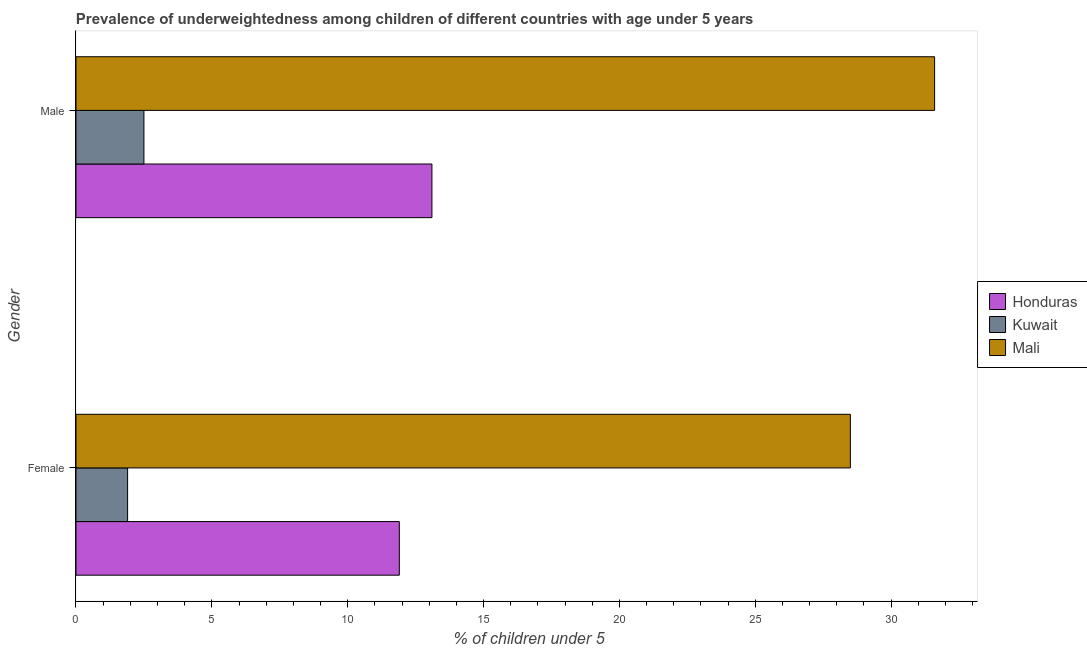What is the percentage of underweighted female children in Kuwait?
Your response must be concise. 1.9. Across all countries, what is the maximum percentage of underweighted female children?
Provide a short and direct response. 28.5. Across all countries, what is the minimum percentage of underweighted female children?
Ensure brevity in your answer.  1.9. In which country was the percentage of underweighted male children maximum?
Your response must be concise. Mali. In which country was the percentage of underweighted male children minimum?
Offer a very short reply. Kuwait. What is the total percentage of underweighted female children in the graph?
Make the answer very short. 42.3. What is the difference between the percentage of underweighted male children in Mali and that in Honduras?
Ensure brevity in your answer.  18.5. What is the difference between the percentage of underweighted male children in Mali and the percentage of underweighted female children in Honduras?
Give a very brief answer. 19.7. What is the average percentage of underweighted female children per country?
Your response must be concise. 14.1. What is the difference between the percentage of underweighted female children and percentage of underweighted male children in Kuwait?
Provide a succinct answer. -0.6. What is the ratio of the percentage of underweighted female children in Mali to that in Honduras?
Give a very brief answer. 2.39. In how many countries, is the percentage of underweighted male children greater than the average percentage of underweighted male children taken over all countries?
Offer a terse response. 1. What does the 3rd bar from the top in Male represents?
Provide a succinct answer. Honduras. What does the 2nd bar from the bottom in Male represents?
Give a very brief answer. Kuwait. How many bars are there?
Your answer should be compact. 6. Are all the bars in the graph horizontal?
Provide a succinct answer. Yes. What is the difference between two consecutive major ticks on the X-axis?
Keep it short and to the point. 5. Are the values on the major ticks of X-axis written in scientific E-notation?
Your answer should be very brief. No. How are the legend labels stacked?
Provide a short and direct response. Vertical. What is the title of the graph?
Offer a very short reply. Prevalence of underweightedness among children of different countries with age under 5 years. Does "Liechtenstein" appear as one of the legend labels in the graph?
Provide a succinct answer. No. What is the label or title of the X-axis?
Your response must be concise.  % of children under 5. What is the  % of children under 5 of Honduras in Female?
Your response must be concise. 11.9. What is the  % of children under 5 in Kuwait in Female?
Ensure brevity in your answer.  1.9. What is the  % of children under 5 in Mali in Female?
Give a very brief answer. 28.5. What is the  % of children under 5 of Honduras in Male?
Ensure brevity in your answer.  13.1. What is the  % of children under 5 in Kuwait in Male?
Provide a succinct answer. 2.5. What is the  % of children under 5 in Mali in Male?
Your answer should be very brief. 31.6. Across all Gender, what is the maximum  % of children under 5 in Honduras?
Offer a very short reply. 13.1. Across all Gender, what is the maximum  % of children under 5 of Mali?
Your answer should be compact. 31.6. Across all Gender, what is the minimum  % of children under 5 in Honduras?
Provide a succinct answer. 11.9. Across all Gender, what is the minimum  % of children under 5 in Kuwait?
Give a very brief answer. 1.9. Across all Gender, what is the minimum  % of children under 5 of Mali?
Your response must be concise. 28.5. What is the total  % of children under 5 in Honduras in the graph?
Your response must be concise. 25. What is the total  % of children under 5 of Mali in the graph?
Your response must be concise. 60.1. What is the difference between the  % of children under 5 in Mali in Female and that in Male?
Give a very brief answer. -3.1. What is the difference between the  % of children under 5 of Honduras in Female and the  % of children under 5 of Mali in Male?
Offer a terse response. -19.7. What is the difference between the  % of children under 5 in Kuwait in Female and the  % of children under 5 in Mali in Male?
Provide a succinct answer. -29.7. What is the average  % of children under 5 in Kuwait per Gender?
Keep it short and to the point. 2.2. What is the average  % of children under 5 in Mali per Gender?
Your answer should be compact. 30.05. What is the difference between the  % of children under 5 of Honduras and  % of children under 5 of Kuwait in Female?
Your answer should be very brief. 10. What is the difference between the  % of children under 5 of Honduras and  % of children under 5 of Mali in Female?
Give a very brief answer. -16.6. What is the difference between the  % of children under 5 of Kuwait and  % of children under 5 of Mali in Female?
Give a very brief answer. -26.6. What is the difference between the  % of children under 5 in Honduras and  % of children under 5 in Kuwait in Male?
Offer a very short reply. 10.6. What is the difference between the  % of children under 5 of Honduras and  % of children under 5 of Mali in Male?
Provide a short and direct response. -18.5. What is the difference between the  % of children under 5 of Kuwait and  % of children under 5 of Mali in Male?
Your response must be concise. -29.1. What is the ratio of the  % of children under 5 of Honduras in Female to that in Male?
Offer a very short reply. 0.91. What is the ratio of the  % of children under 5 in Kuwait in Female to that in Male?
Provide a succinct answer. 0.76. What is the ratio of the  % of children under 5 in Mali in Female to that in Male?
Offer a very short reply. 0.9. What is the difference between the highest and the second highest  % of children under 5 of Honduras?
Provide a succinct answer. 1.2. What is the difference between the highest and the second highest  % of children under 5 of Mali?
Provide a short and direct response. 3.1. What is the difference between the highest and the lowest  % of children under 5 of Honduras?
Ensure brevity in your answer.  1.2. What is the difference between the highest and the lowest  % of children under 5 of Mali?
Your answer should be very brief. 3.1. 